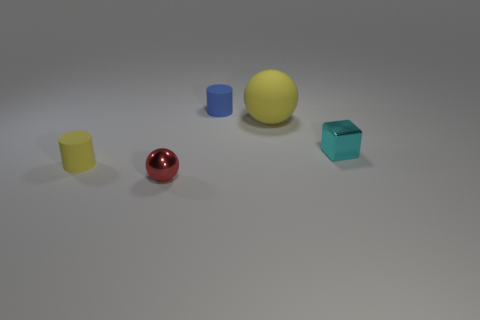What number of other things are there of the same size as the cyan metal object?
Provide a short and direct response. 3. Is the cylinder right of the small sphere made of the same material as the small cyan cube?
Your answer should be very brief. No. How many other objects are there of the same color as the large object?
Offer a very short reply. 1. What number of other objects are the same shape as the tiny yellow object?
Your response must be concise. 1. There is a small rubber thing in front of the small cyan cube; is it the same shape as the small thing behind the large yellow rubber thing?
Make the answer very short. Yes. Is the number of large yellow things in front of the red thing the same as the number of cyan metal things that are behind the tiny yellow rubber thing?
Provide a succinct answer. No. What is the shape of the small shiny object that is behind the tiny yellow matte thing left of the large rubber ball that is right of the small blue cylinder?
Make the answer very short. Cube. Do the small cylinder behind the yellow cylinder and the yellow object on the left side of the red metal ball have the same material?
Provide a succinct answer. Yes. What is the shape of the tiny rubber object that is to the right of the tiny red metal sphere?
Your answer should be compact. Cylinder. Is the number of large blue rubber blocks less than the number of cyan objects?
Your answer should be compact. Yes. 